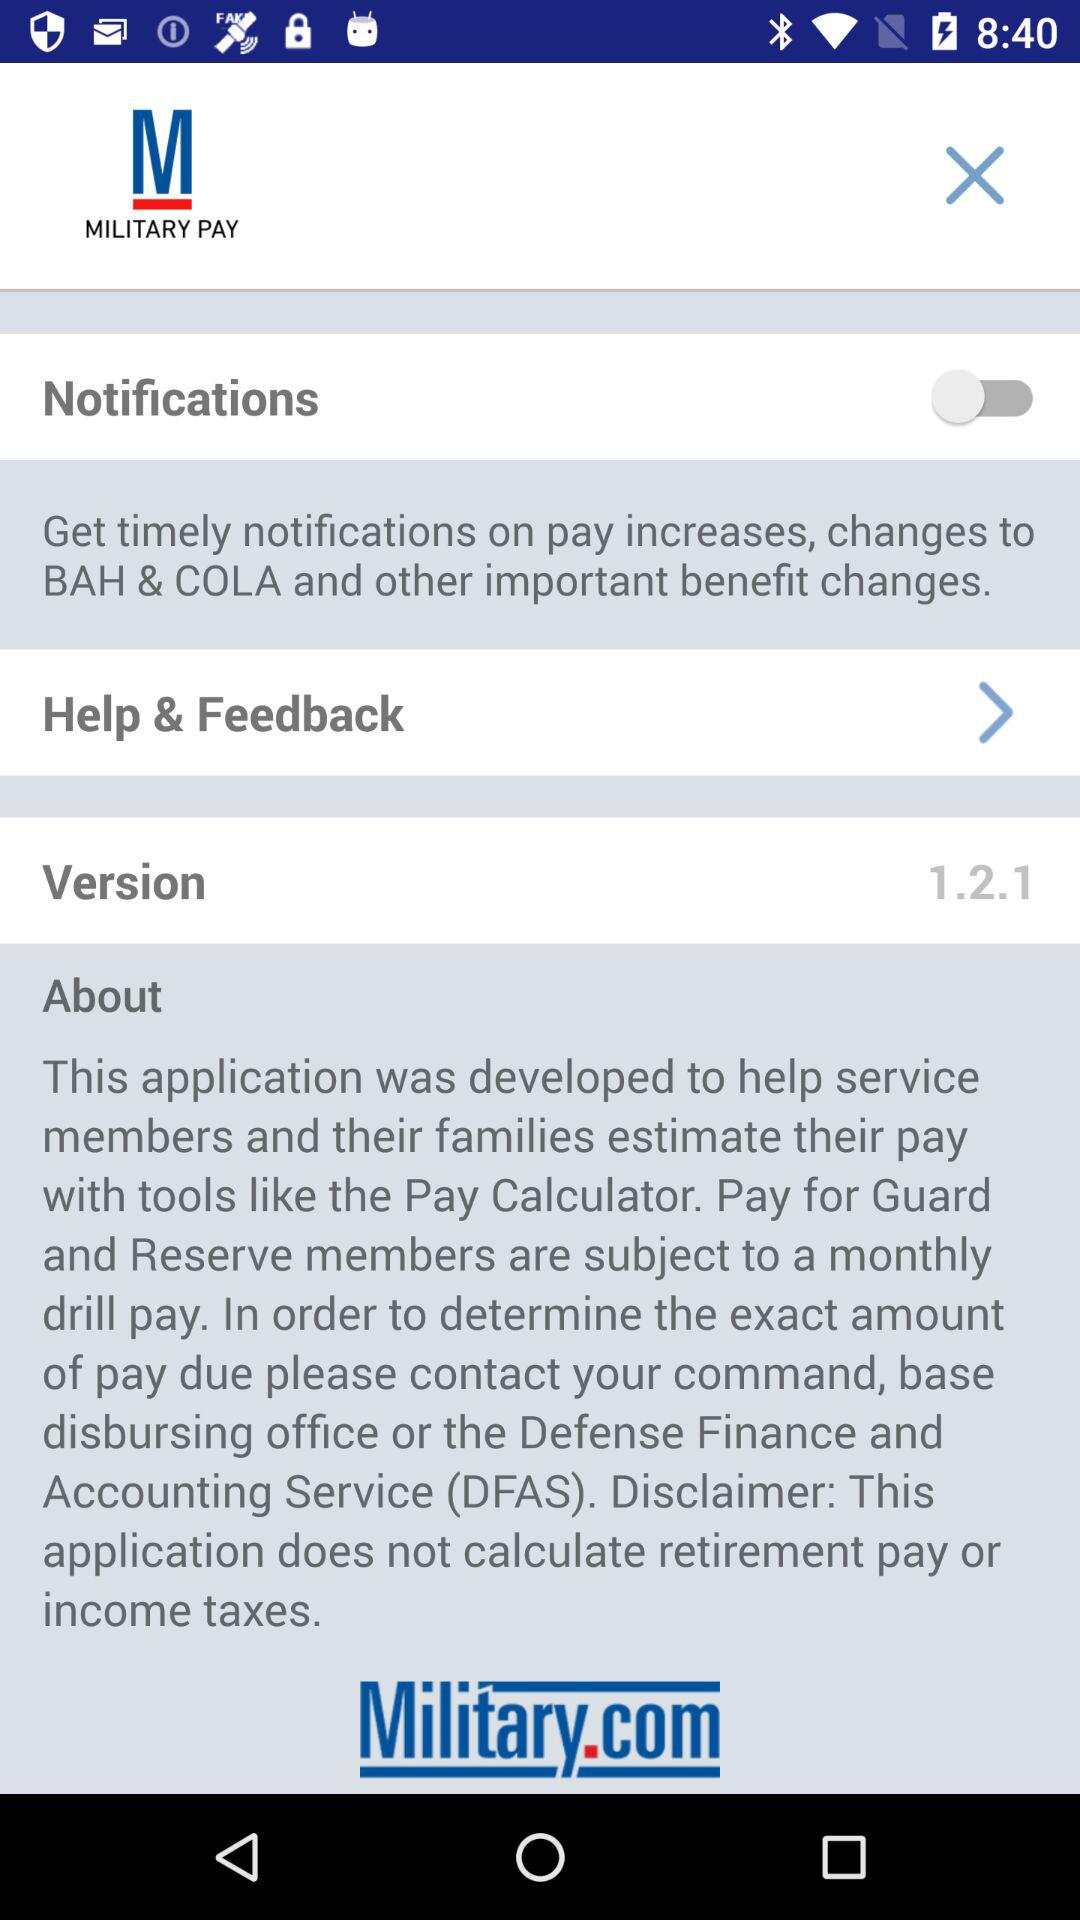What is the status of "Notifications"? The status is "off". 